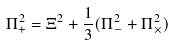<formula> <loc_0><loc_0><loc_500><loc_500>\Pi _ { + } ^ { 2 } = \Xi ^ { 2 } + \frac { 1 } { 3 } ( \Pi _ { - } ^ { 2 } + \Pi _ { \times } ^ { 2 } )</formula> 